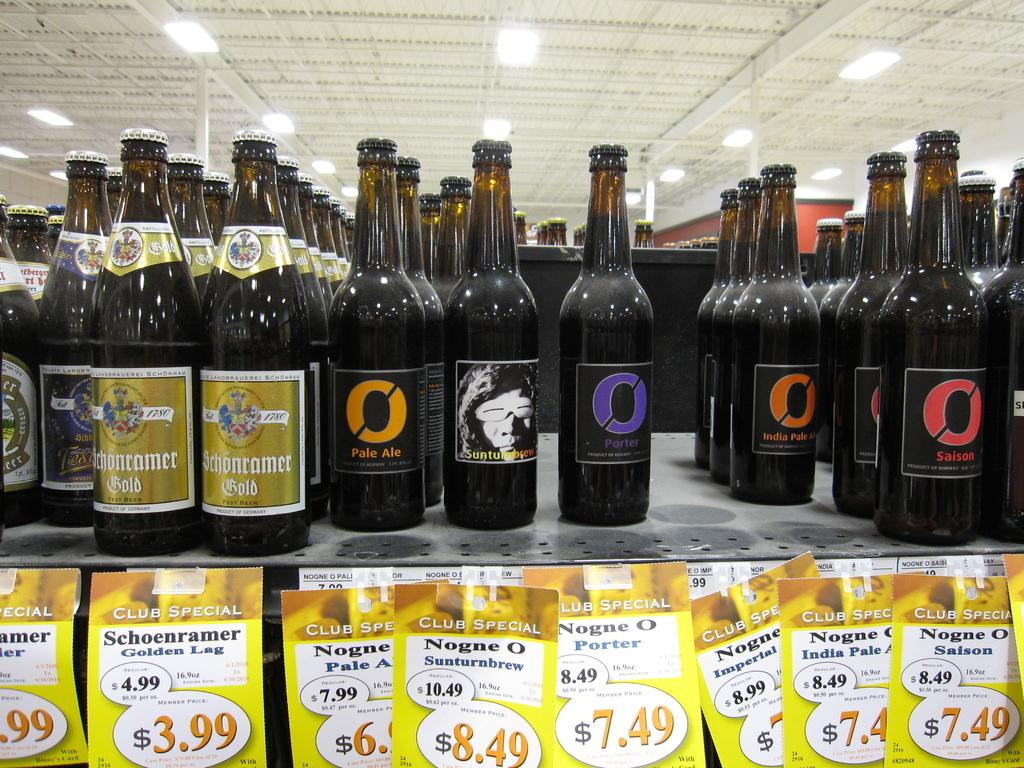Provide a one-sentence caption for the provided image. A bottle of Pale Ale sitting on a shelf with many other bottles. 